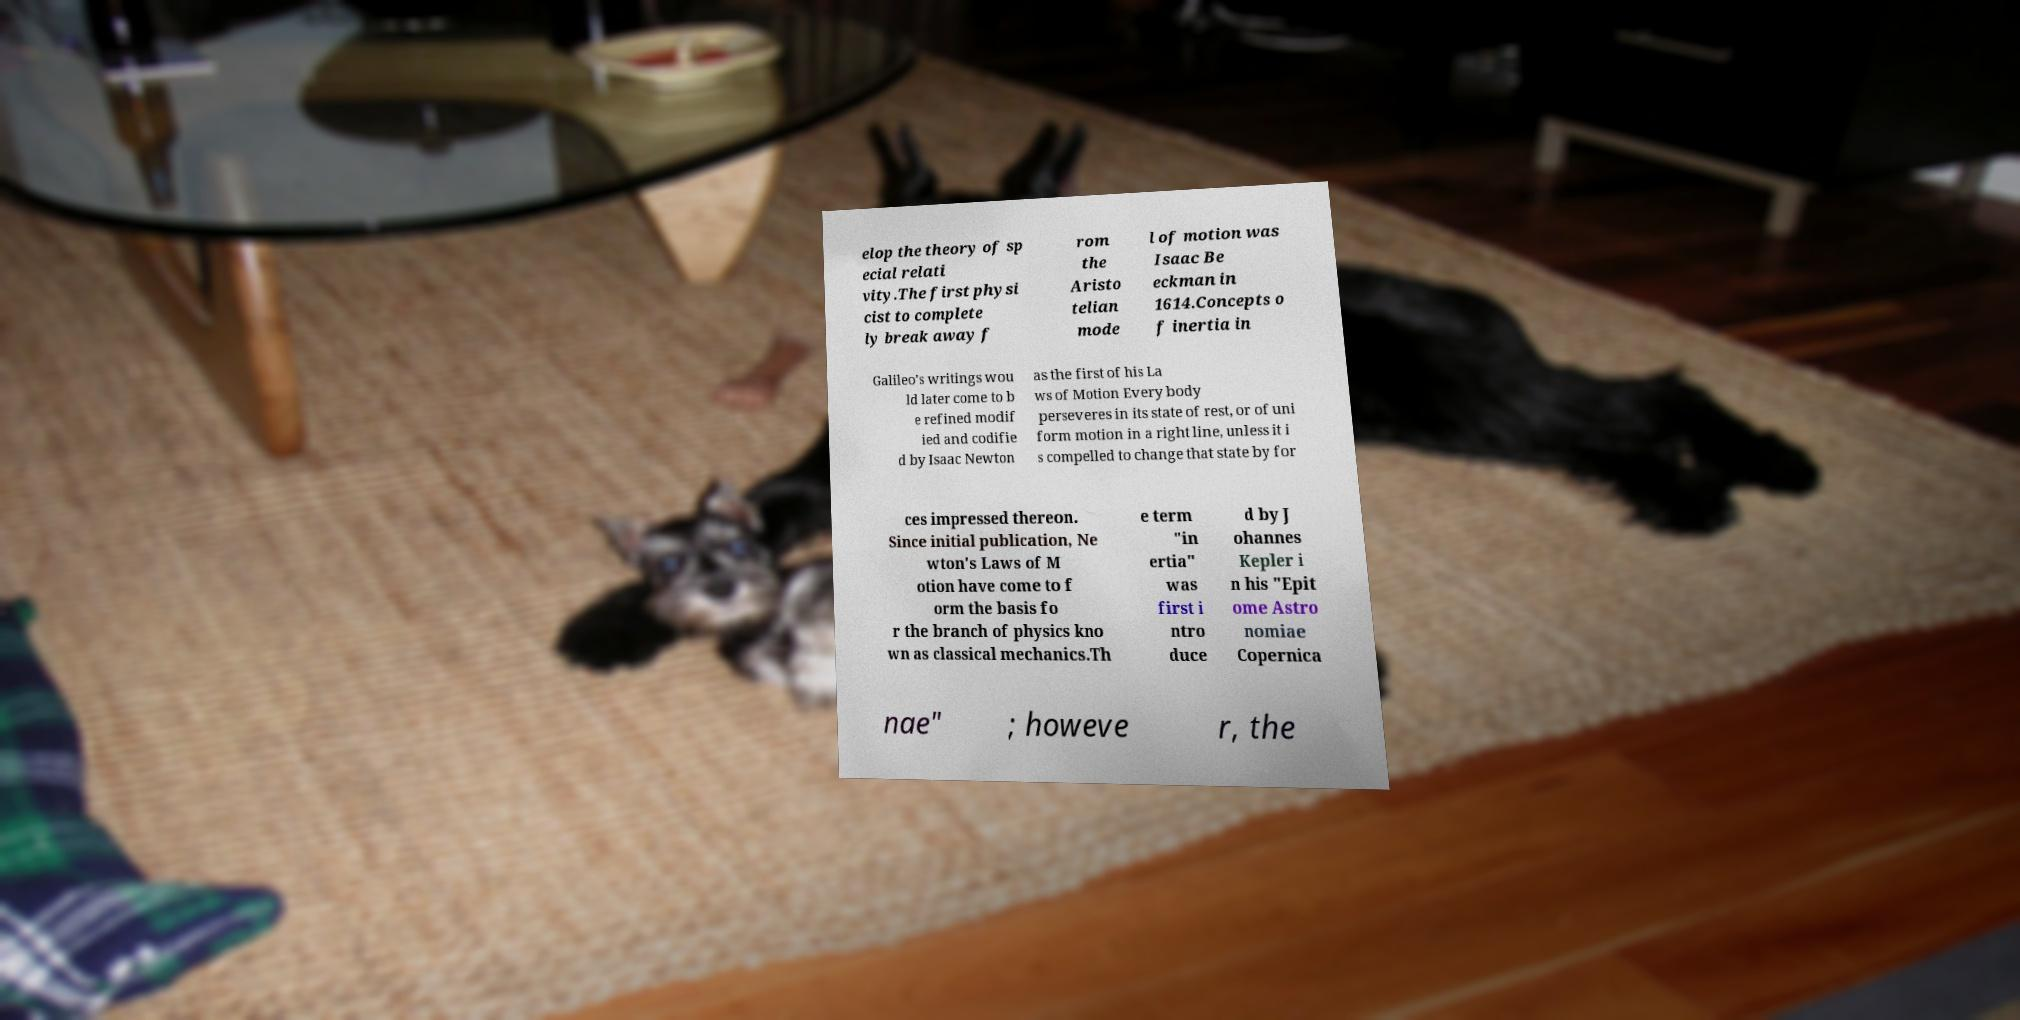There's text embedded in this image that I need extracted. Can you transcribe it verbatim? elop the theory of sp ecial relati vity.The first physi cist to complete ly break away f rom the Aristo telian mode l of motion was Isaac Be eckman in 1614.Concepts o f inertia in Galileo's writings wou ld later come to b e refined modif ied and codifie d by Isaac Newton as the first of his La ws of Motion Every body perseveres in its state of rest, or of uni form motion in a right line, unless it i s compelled to change that state by for ces impressed thereon. Since initial publication, Ne wton's Laws of M otion have come to f orm the basis fo r the branch of physics kno wn as classical mechanics.Th e term "in ertia" was first i ntro duce d by J ohannes Kepler i n his "Epit ome Astro nomiae Copernica nae" ; howeve r, the 